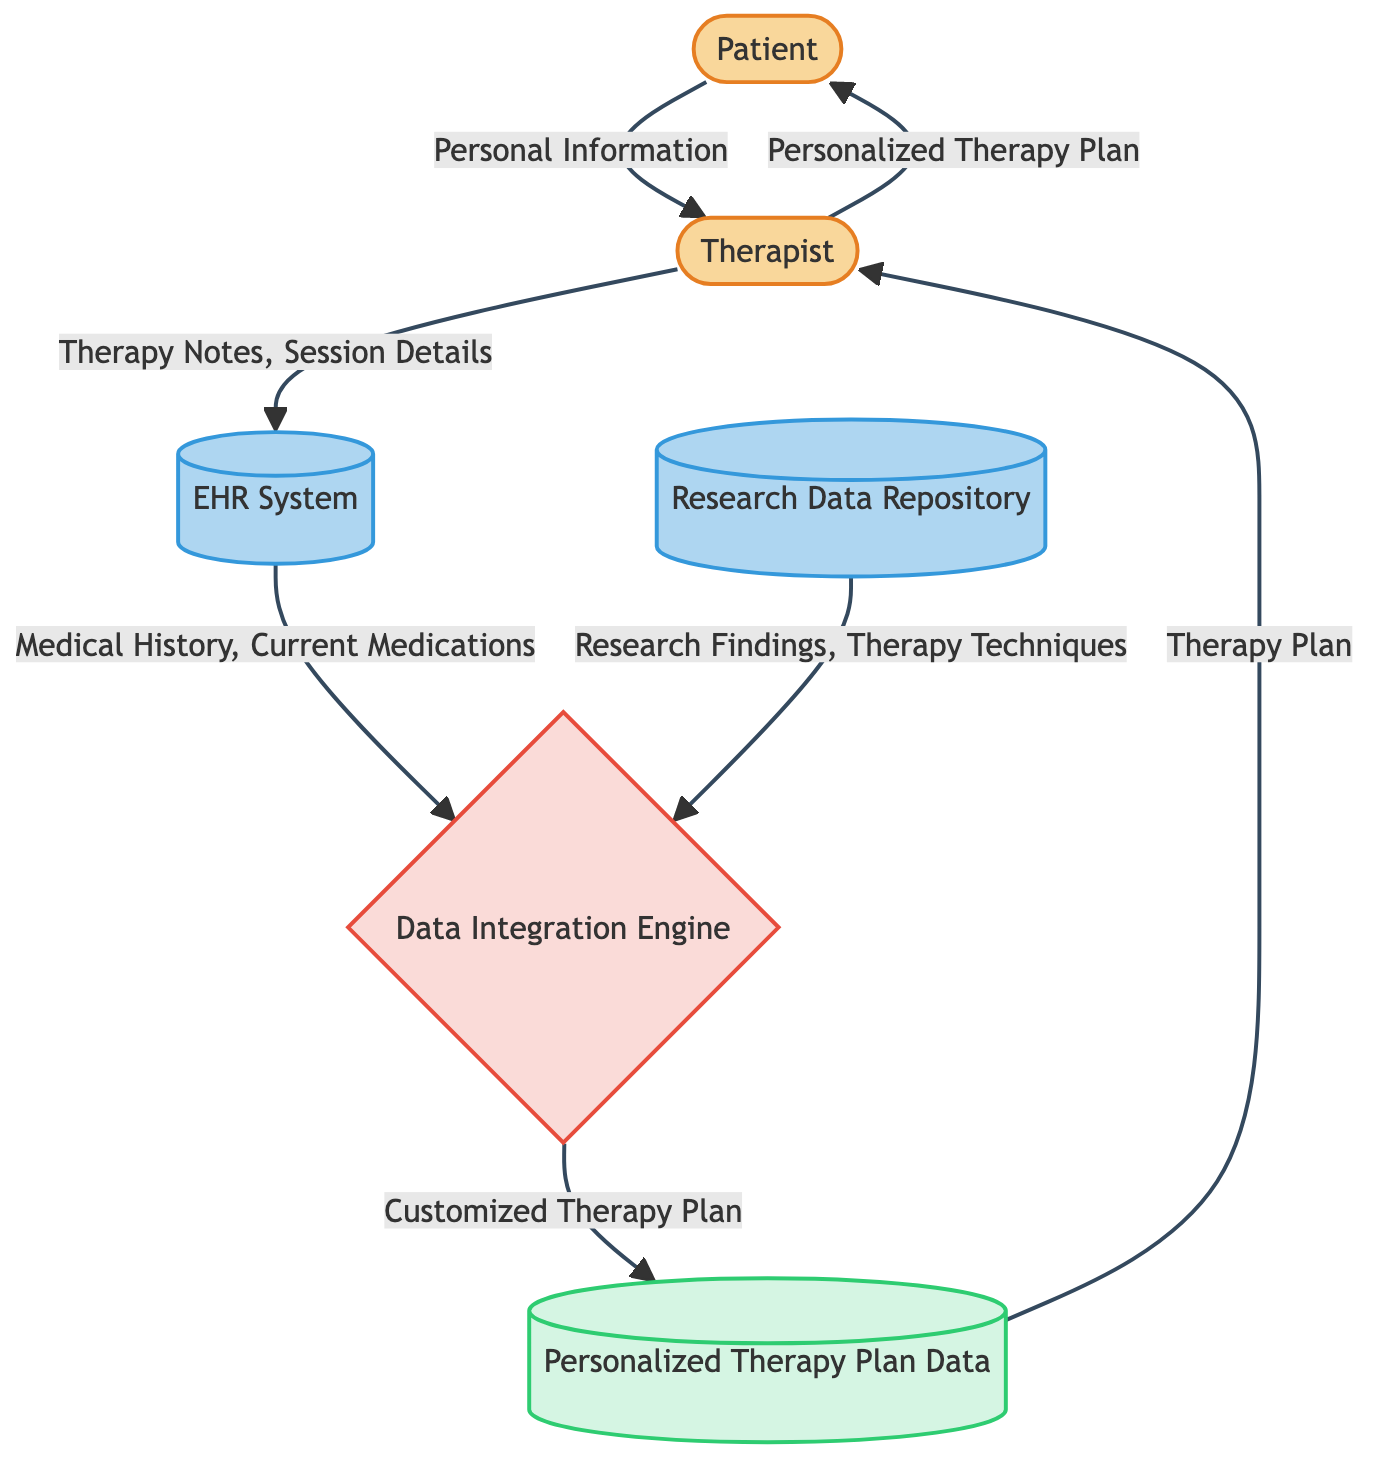What are the two external entities in the diagram? The diagram indicates that the two external entities are the Patient and the Therapist, as shown by their classifications in the diagram.
Answer: Patient and Therapist How many processes are depicted in the diagram? There is one process represented in the diagram, which is the Data Integration Engine. This is determined by examining the labeled nodes and counting the instances of the process symbol.
Answer: One What type of data does the Therapist send to the EHR System? The Therapist updates the EHR System with Therapy Notes and Session Details based on the arrow indicating this flow in the diagram.
Answer: Therapy Notes, Session Details Which entity retrieves Medical History and Current Medications? The EHR System retrieves the Medical History and Current Medications as indicated by the data flow from the EHR System to the Data Integration Engine.
Answer: EHR System What data flows from the Data Integration Engine to the Personalized Therapy Plan Data? The Customized Therapy Plan flows from the Data Integration Engine to the Personalized Therapy Plan Data according to the labeled arrows in the diagram.
Answer: Customized Therapy Plan What is the final output to the Patient from the Therapist? The final output to the Patient from the Therapist is the Personalized Therapy Plan as indicated by the final flow in the diagram.
Answer: Personalized Therapy Plan Which entity provides Research Findings and Therapy Techniques? The Research Data Repository provides Research Findings and Therapy Techniques as shown by the data flow from this entity to the Data Integration Engine.
Answer: Research Data Repository How many data flows are represented in the diagram? The diagram illustrates a total of six data flows based on the connections drawn between entities and the processes shown.
Answer: Six 